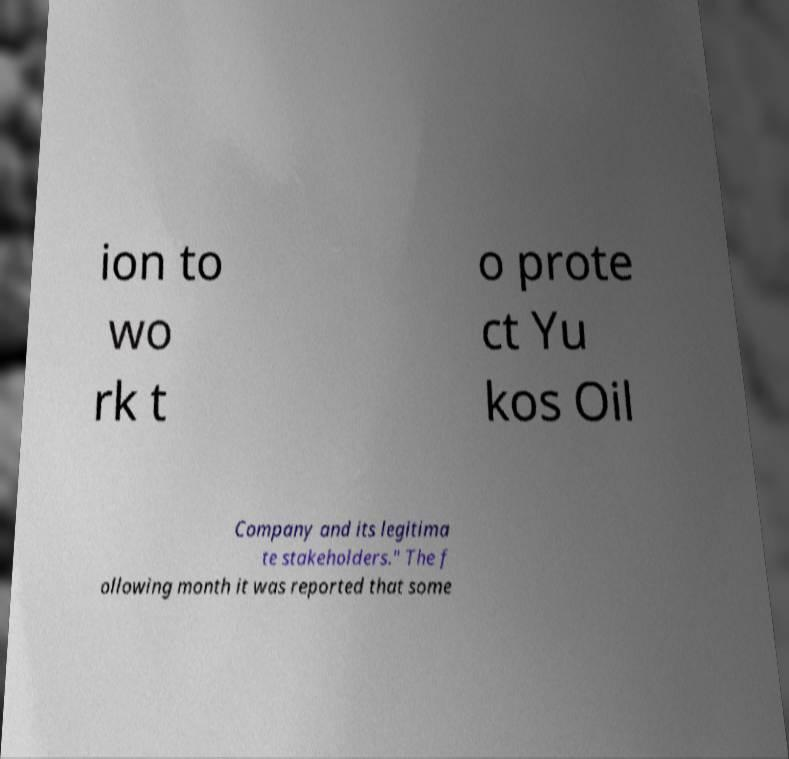Can you read and provide the text displayed in the image?This photo seems to have some interesting text. Can you extract and type it out for me? ion to wo rk t o prote ct Yu kos Oil Company and its legitima te stakeholders." The f ollowing month it was reported that some 